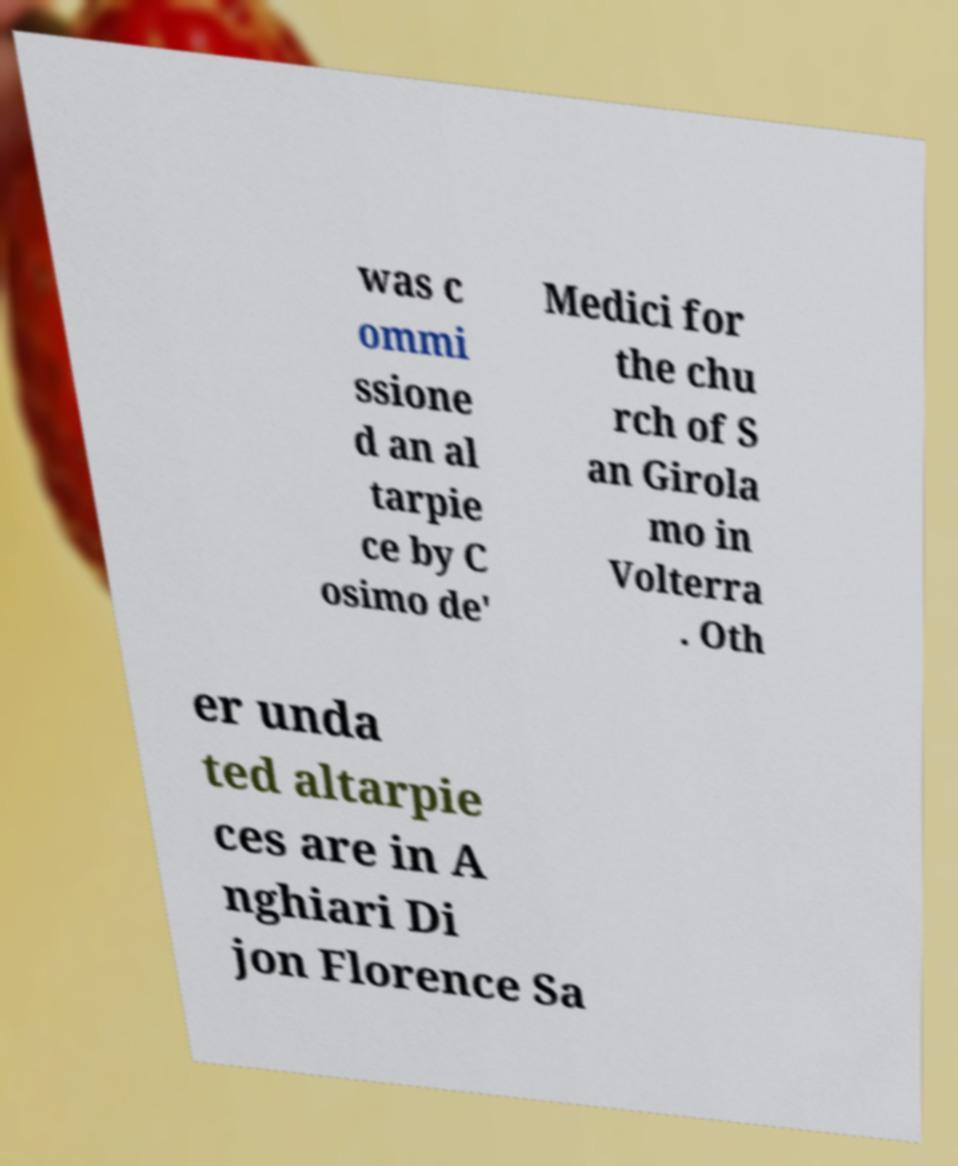I need the written content from this picture converted into text. Can you do that? was c ommi ssione d an al tarpie ce by C osimo de' Medici for the chu rch of S an Girola mo in Volterra . Oth er unda ted altarpie ces are in A nghiari Di jon Florence Sa 